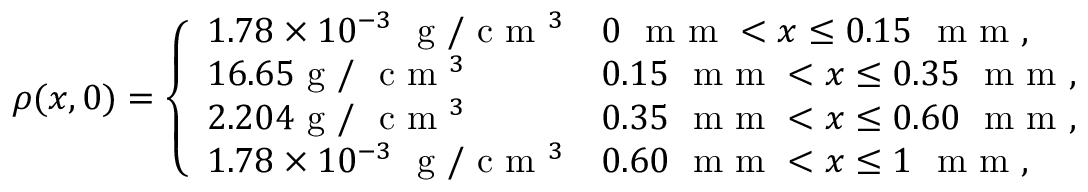Convert formula to latex. <formula><loc_0><loc_0><loc_500><loc_500>\rho ( x , 0 ) = \left \{ \begin{array} { l l } { 1 . 7 8 \times 1 0 ^ { - 3 } g / c m ^ { 3 } } & { 0 m m < x \leq 0 . 1 5 m m , } \\ { 1 6 . 6 5 g / c m ^ { 3 } } & { 0 . 1 5 m m < x \leq 0 . 3 5 m m , } \\ { 2 . 2 0 4 g / c m ^ { 3 } } & { 0 . 3 5 m m < x \leq 0 . 6 0 m m , } \\ { 1 . 7 8 \times 1 0 ^ { - 3 } g / c m ^ { 3 } } & { 0 . 6 0 m m < x \leq 1 m m , } \end{array}</formula> 